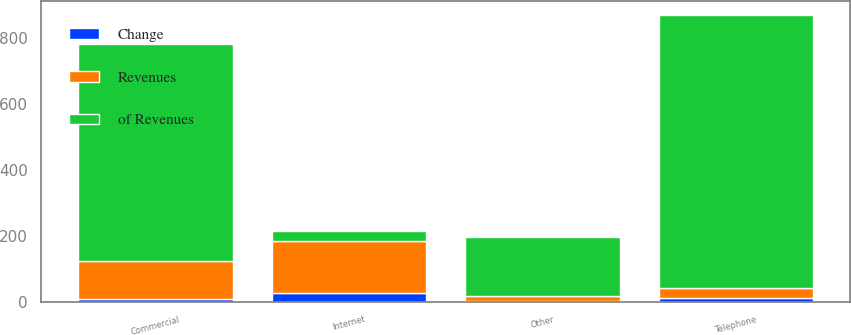<chart> <loc_0><loc_0><loc_500><loc_500><stacked_bar_chart><ecel><fcel>Internet<fcel>Telephone<fcel>Commercial<fcel>Other<nl><fcel>of Revenues<fcel>30<fcel>828<fcel>658<fcel>179<nl><fcel>Change<fcel>25<fcel>11<fcel>9<fcel>2<nl><fcel>Revenues<fcel>158<fcel>30<fcel>114<fcel>16<nl></chart> 